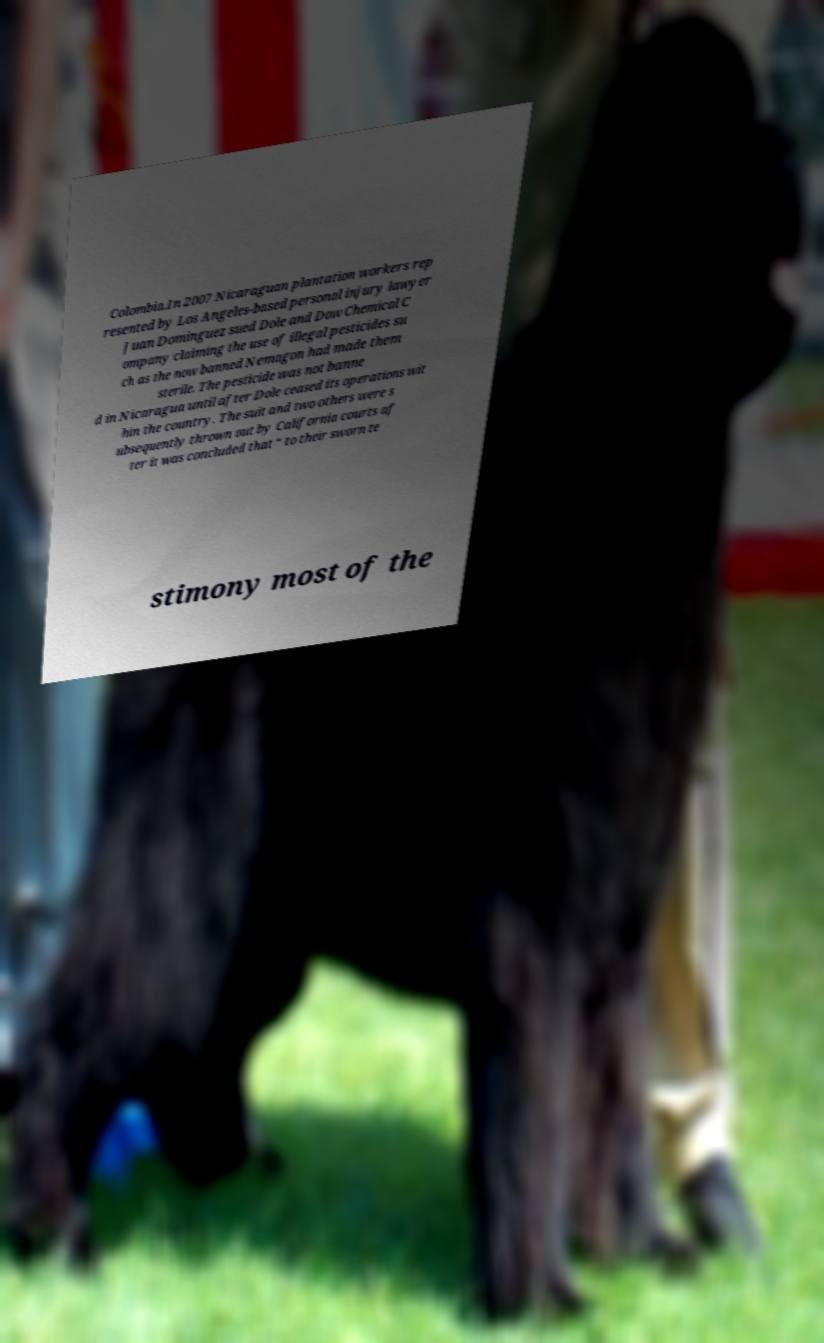Please identify and transcribe the text found in this image. Colombia.In 2007 Nicaraguan plantation workers rep resented by Los Angeles-based personal injury lawyer Juan Dominguez sued Dole and Dow Chemical C ompany claiming the use of illegal pesticides su ch as the now banned Nemagon had made them sterile. The pesticide was not banne d in Nicaragua until after Dole ceased its operations wit hin the country. The suit and two others were s ubsequently thrown out by California courts af ter it was concluded that “ to their sworn te stimony most of the 